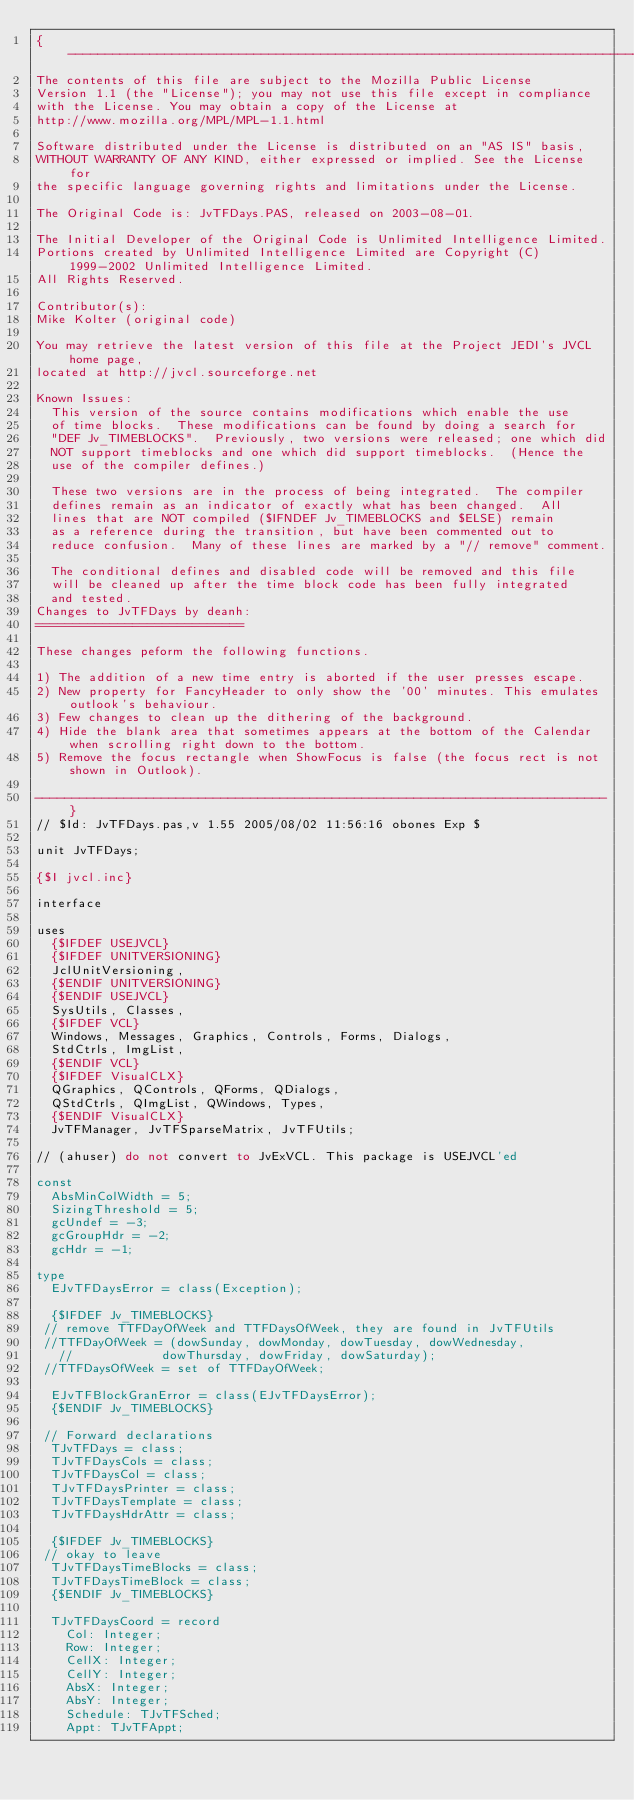Convert code to text. <code><loc_0><loc_0><loc_500><loc_500><_Pascal_>{-----------------------------------------------------------------------------
The contents of this file are subject to the Mozilla Public License
Version 1.1 (the "License"); you may not use this file except in compliance
with the License. You may obtain a copy of the License at
http://www.mozilla.org/MPL/MPL-1.1.html

Software distributed under the License is distributed on an "AS IS" basis,
WITHOUT WARRANTY OF ANY KIND, either expressed or implied. See the License for
the specific language governing rights and limitations under the License.

The Original Code is: JvTFDays.PAS, released on 2003-08-01.

The Initial Developer of the Original Code is Unlimited Intelligence Limited.
Portions created by Unlimited Intelligence Limited are Copyright (C) 1999-2002 Unlimited Intelligence Limited.
All Rights Reserved.

Contributor(s):
Mike Kolter (original code)

You may retrieve the latest version of this file at the Project JEDI's JVCL home page,
located at http://jvcl.sourceforge.net

Known Issues:
  This version of the source contains modifications which enable the use
  of time blocks.  These modifications can be found by doing a search for
  "DEF Jv_TIMEBLOCKS".  Previously, two versions were released; one which did
  NOT support timeblocks and one which did support timeblocks.  (Hence the
  use of the compiler defines.)

  These two versions are in the process of being integrated.  The compiler
  defines remain as an indicator of exactly what has been changed.  All
  lines that are NOT compiled ($IFNDEF Jv_TIMEBLOCKS and $ELSE) remain
  as a reference during the transition, but have been commented out to
  reduce confusion.  Many of these lines are marked by a "// remove" comment.

  The conditional defines and disabled code will be removed and this file
  will be cleaned up after the time block code has been fully integrated
  and tested.
Changes to JvTFDays by deanh:
============================

These changes peform the following functions.

1) The addition of a new time entry is aborted if the user presses escape.
2) New property for FancyHeader to only show the '00' minutes. This emulates outlook's behaviour.
3) Few changes to clean up the dithering of the background.
4) Hide the blank area that sometimes appears at the bottom of the Calendar when scrolling right down to the bottom.
5) Remove the focus rectangle when ShowFocus is false (the focus rect is not shown in Outlook).

-----------------------------------------------------------------------------}
// $Id: JvTFDays.pas,v 1.55 2005/08/02 11:56:16 obones Exp $

unit JvTFDays;

{$I jvcl.inc}

interface

uses
  {$IFDEF USEJVCL}
  {$IFDEF UNITVERSIONING}
  JclUnitVersioning,
  {$ENDIF UNITVERSIONING}
  {$ENDIF USEJVCL}
  SysUtils, Classes,
  {$IFDEF VCL}
  Windows, Messages, Graphics, Controls, Forms, Dialogs,
  StdCtrls, ImgList,
  {$ENDIF VCL}
  {$IFDEF VisualCLX}
  QGraphics, QControls, QForms, QDialogs,
  QStdCtrls, QImgList, QWindows, Types,
  {$ENDIF VisualCLX}
  JvTFManager, JvTFSparseMatrix, JvTFUtils;

// (ahuser) do not convert to JvExVCL. This package is USEJVCL'ed

const
  AbsMinColWidth = 5;
  SizingThreshold = 5;
  gcUndef = -3;
  gcGroupHdr = -2;
  gcHdr = -1;

type
  EJvTFDaysError = class(Exception);

  {$IFDEF Jv_TIMEBLOCKS}
 // remove TTFDayOfWeek and TTFDaysOfWeek, they are found in JvTFUtils
 //TTFDayOfWeek = (dowSunday, dowMonday, dowTuesday, dowWednesday,
   //            dowThursday, dowFriday, dowSaturday);
 //TTFDaysOfWeek = set of TTFDayOfWeek;

  EJvTFBlockGranError = class(EJvTFDaysError);
  {$ENDIF Jv_TIMEBLOCKS}

 // Forward declarations
  TJvTFDays = class;
  TJvTFDaysCols = class;
  TJvTFDaysCol = class;
  TJvTFDaysPrinter = class;
  TJvTFDaysTemplate = class;
  TJvTFDaysHdrAttr = class;

  {$IFDEF Jv_TIMEBLOCKS}
 // okay to leave
  TJvTFDaysTimeBlocks = class;
  TJvTFDaysTimeBlock = class;
  {$ENDIF Jv_TIMEBLOCKS}

  TJvTFDaysCoord = record
    Col: Integer;
    Row: Integer;
    CellX: Integer;
    CellY: Integer;
    AbsX: Integer;
    AbsY: Integer;
    Schedule: TJvTFSched;
    Appt: TJvTFAppt;</code> 